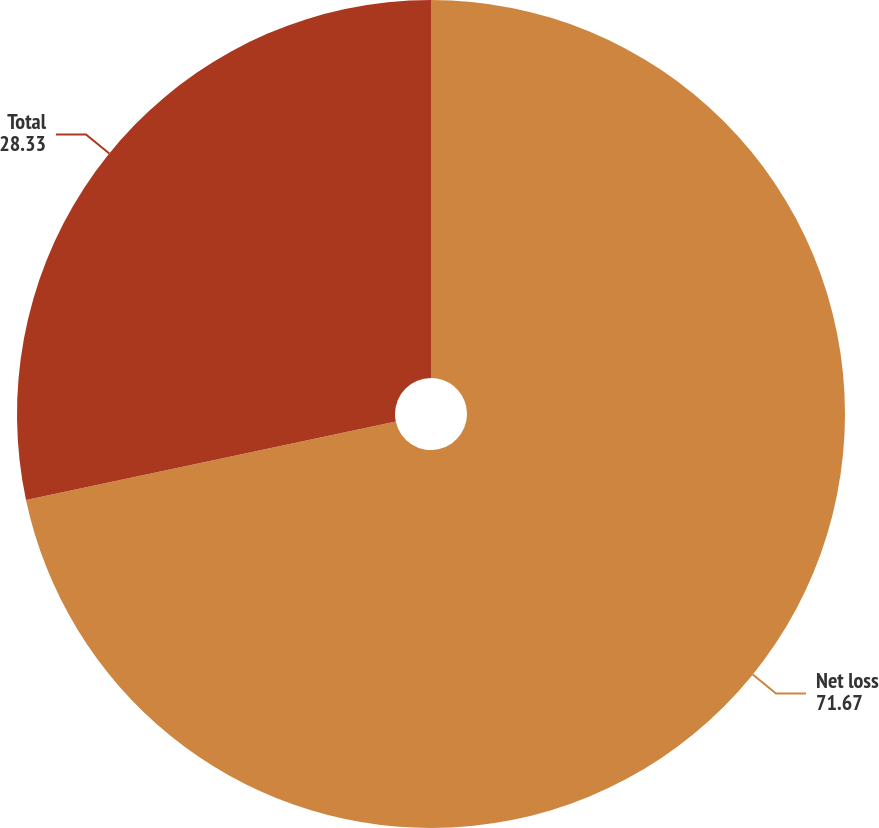<chart> <loc_0><loc_0><loc_500><loc_500><pie_chart><fcel>Net loss<fcel>Total<nl><fcel>71.67%<fcel>28.33%<nl></chart> 